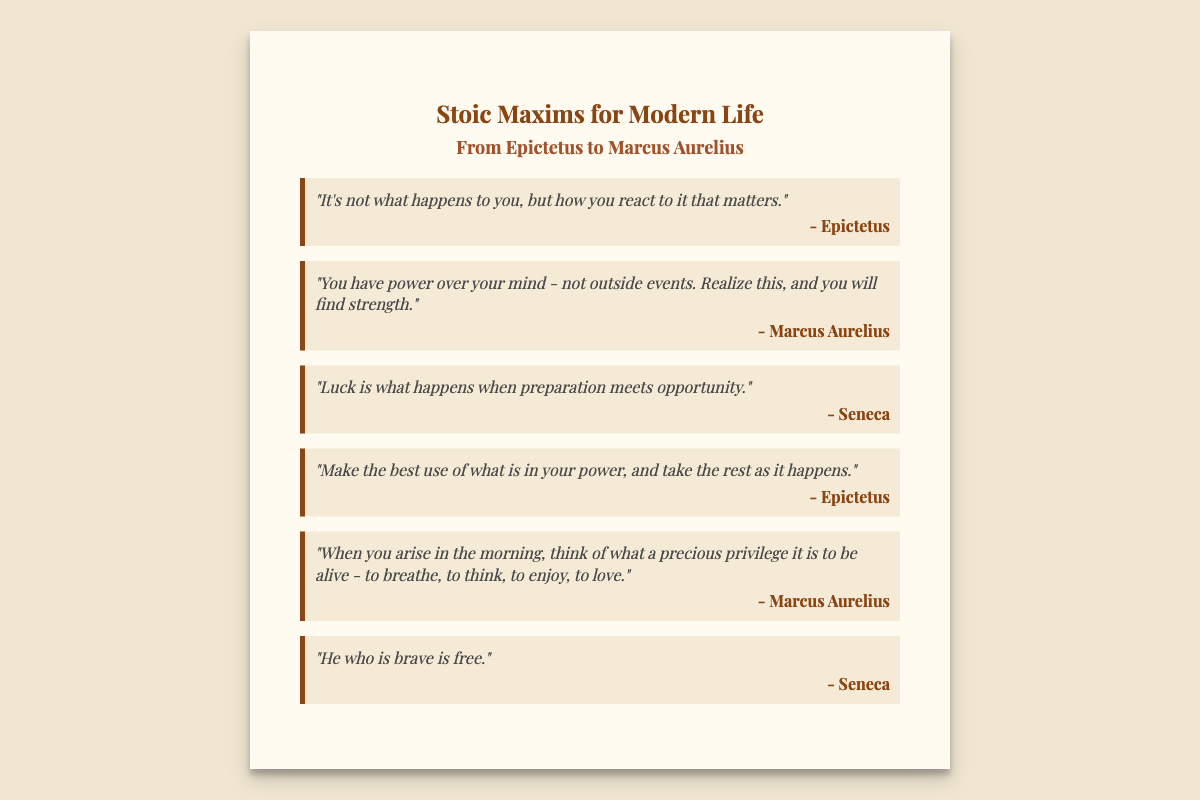what is the title of the card? The title is prominently displayed at the top of the card and is "Stoic Maxims for Modern Life."
Answer: Stoic Maxims for Modern Life who is the author of the quote about reacting to events? The author of this quote is listed beneath the quote on the card.
Answer: Epictetus how many maxims are presented on the card? The number of maxims can be counted from the sections presented in the document.
Answer: Six which philosopher said, "Luck is what happens when preparation meets opportunity"? This is a specific quote attributed to a philosopher mentioned in the document.
Answer: Seneca what is the color of the card's background? The color can be seen visually in the document as a light shade, described in the CSS.
Answer: #fffbf0 what is the message of the maxim "You have power over your mind"? It expresses the Stoic belief in personal control and inner strength, as stated in the quote.
Answer: Realize this, and you will find strength 